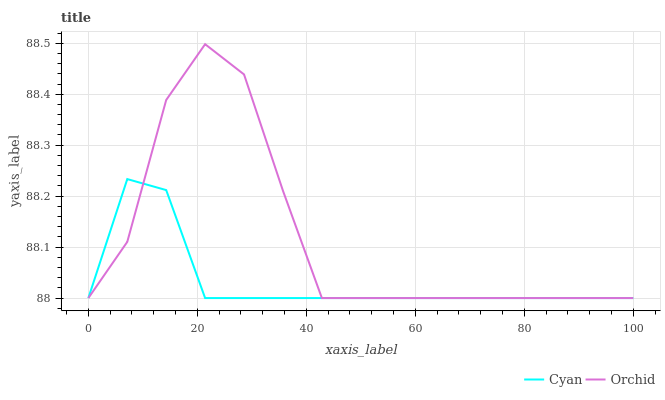Does Cyan have the minimum area under the curve?
Answer yes or no. Yes. Does Orchid have the maximum area under the curve?
Answer yes or no. Yes. Does Orchid have the minimum area under the curve?
Answer yes or no. No. Is Cyan the smoothest?
Answer yes or no. Yes. Is Orchid the roughest?
Answer yes or no. Yes. Is Orchid the smoothest?
Answer yes or no. No. Does Cyan have the lowest value?
Answer yes or no. Yes. Does Orchid have the highest value?
Answer yes or no. Yes. Does Cyan intersect Orchid?
Answer yes or no. Yes. Is Cyan less than Orchid?
Answer yes or no. No. Is Cyan greater than Orchid?
Answer yes or no. No. 